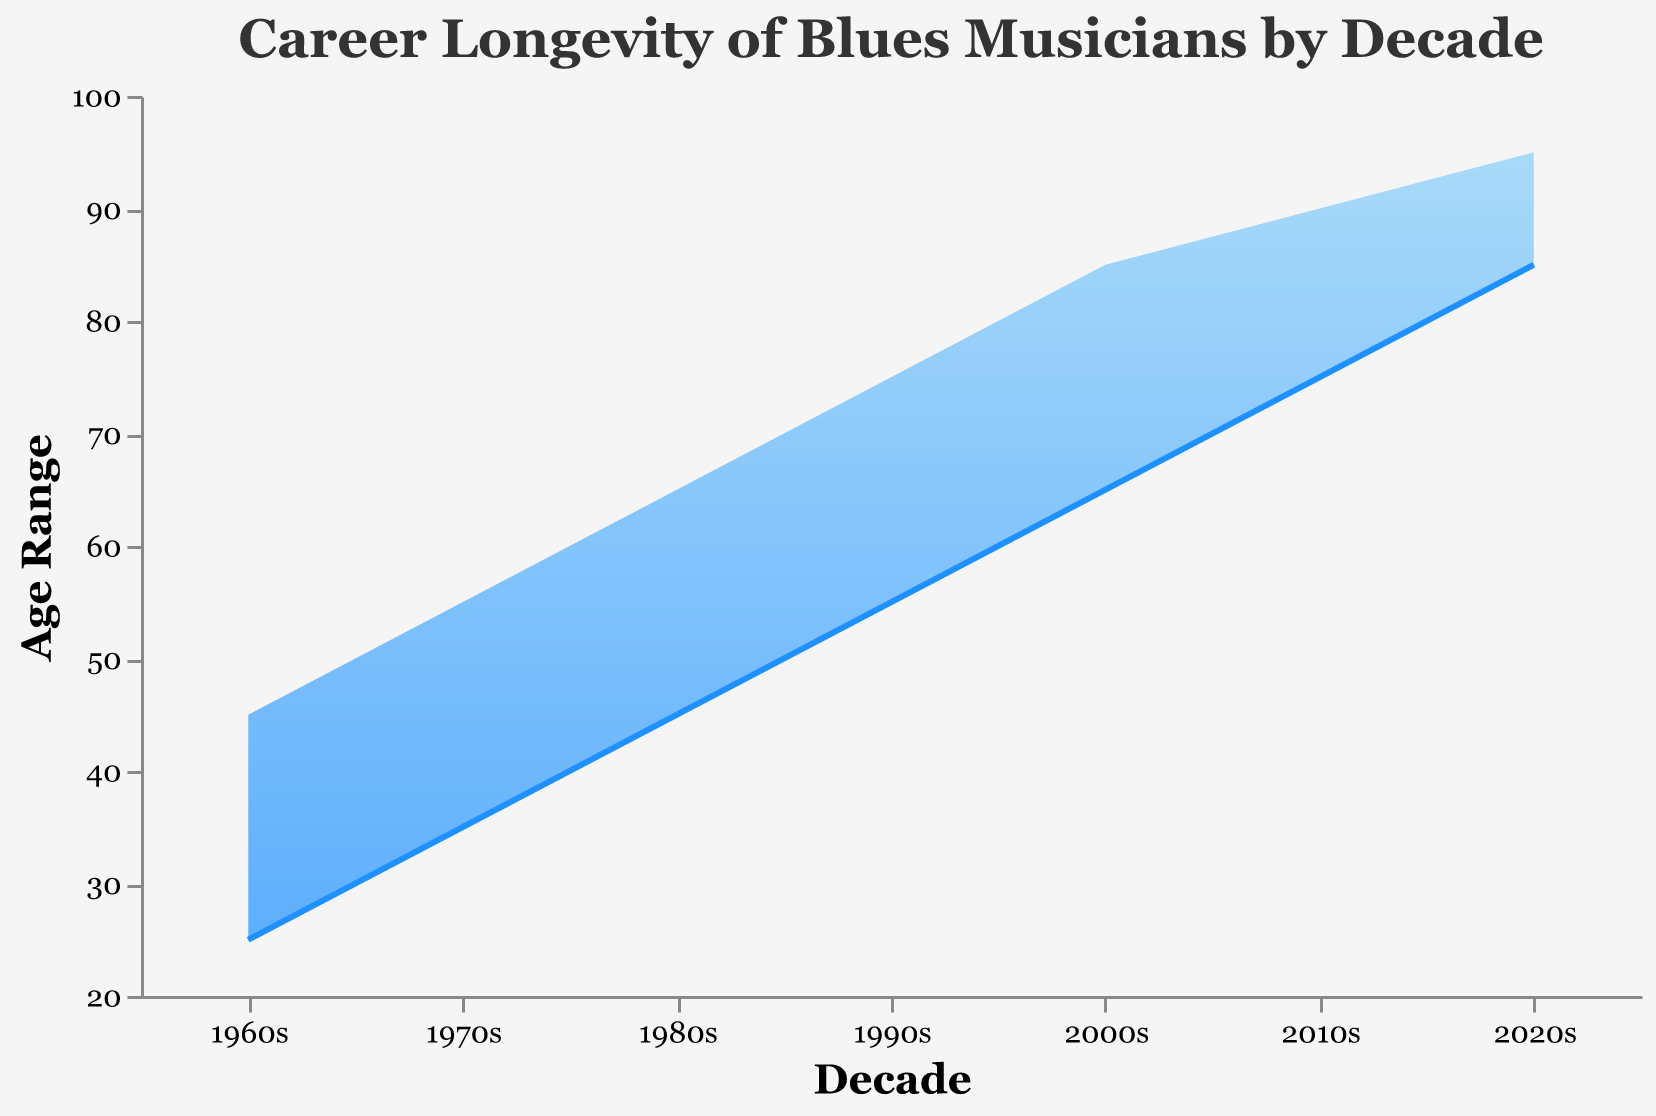What is the age range of blues musicians in the 1960s? The figure identifies the start and end ages for each decade. For the 1960s, the start age is 25 and the end age is 45. Therefore, the age range is 45 - 25 = 20 years.
Answer: 20 years What are the axes labeled? By looking at the figure, you can see the x-axis is labeled "Decade" and the y-axis is labeled "Age Range."
Answer: "Decade", "Age Range" How does the age range of blues musicians change from the 1970s to the 1980s? Refer to the figure to compare both decades. In the 1970s, the age range is 35-55. In the 1980s, it's 45-65. The range is consistent, but the starting and ending ages increase by 10 years.
Answer: Increases by 10 years Which decade shows the greatest age range and what is it? Observe the widest span vertically in the figure. The largest range is 1960s within ages 25-45. Confirming: 45 - 25 = 20 years.
Answer: 1960s, 20 years What is the trend in the starting age of blues musicians from 1960s to 2020s? Examine the 'start_age' changes across decades. Notice it steadily increases with each decade from 25 in 1960s to 85 in 2020s. This indicates an upward trend.
Answer: Increasing trend How many decades are covered in the chart? Look at the number of data points marked along the x-axis. There are data points from the 1960s to the 2020s, which adds up to seven decades.
Answer: 7 decades Which decade has the smallest end age and what is that age? Find the lowest point on the y-axis for the 'end_age.' The 1960s has the smallest end age of 45 years.
Answer: 1960s, 45 years Calculate the average start age of musicians over all decades. List the start ages: 25, 35, 45, 55, 65, 75, 85. Sum them up (25+35+45+55+65+75+85=385) and divide by 7 (number of decades). 385/7 = 55
Answer: 55 Compare the end age of musicians in the 1990s with the 2010s. Which is greater and by how much? Referencing 'end_age' for the 1990s (75) and 2010s (90). Compute the difference: 90 - 75 = 15. The 2010s show a greater end age by 15 years.
Answer: 2010s, 15 years 